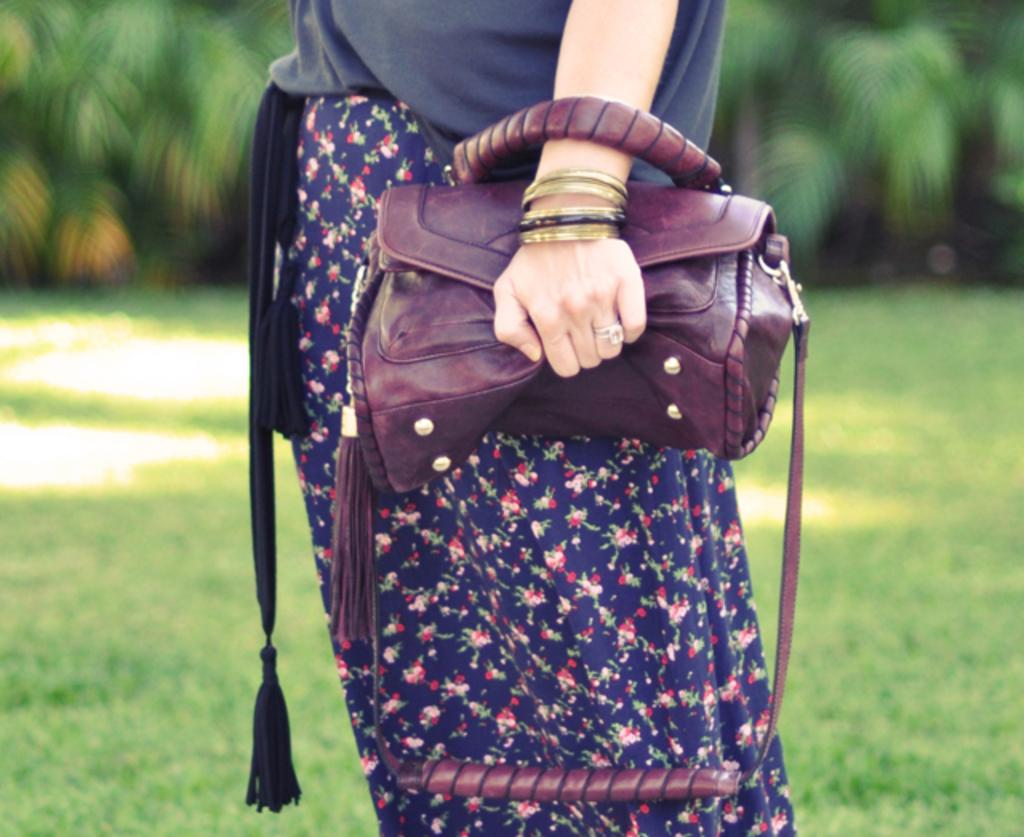Who is present in the image? There is a person in the image. What is the person wearing on her hand? The person is wearing bangles on her hand. What type of handbag is the person holding? The person is holding a handbag with a gray color. What type of flooring can be seen in the image? There is grass on the floor in the image. What can be seen in the background of the image? There are trees visible at the back side of the image. What religion does the expert discuss at the station in the image? There is no expert or station present in the image; it features a person with bangles, a gray handbag, grass on the floor, and trees in the background. 